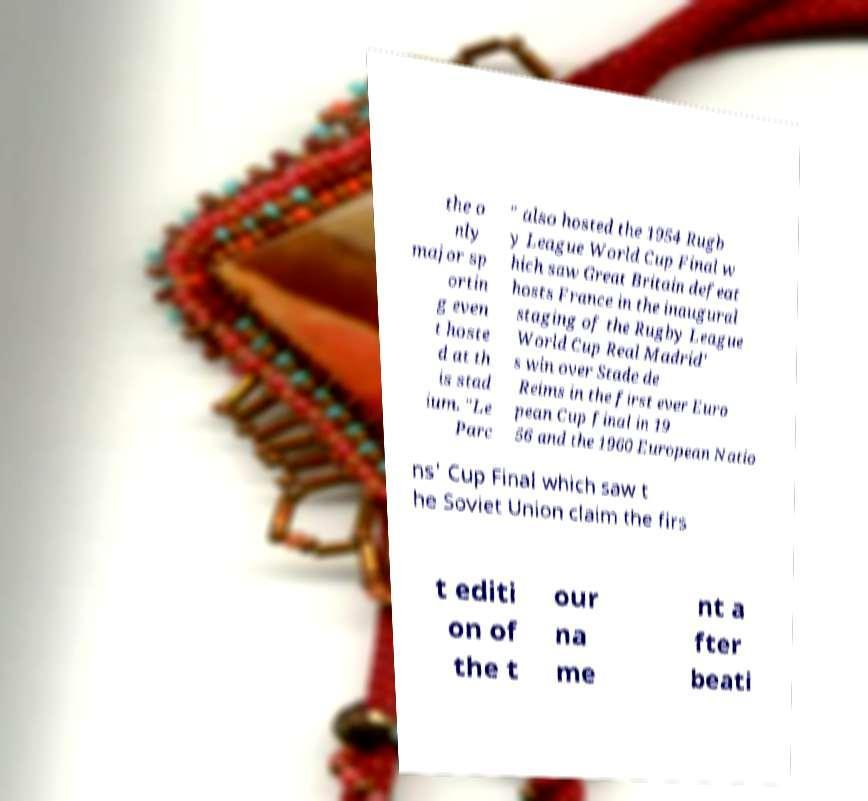Can you read and provide the text displayed in the image?This photo seems to have some interesting text. Can you extract and type it out for me? the o nly major sp ortin g even t hoste d at th is stad ium. "Le Parc " also hosted the 1954 Rugb y League World Cup Final w hich saw Great Britain defeat hosts France in the inaugural staging of the Rugby League World Cup Real Madrid' s win over Stade de Reims in the first ever Euro pean Cup final in 19 56 and the 1960 European Natio ns' Cup Final which saw t he Soviet Union claim the firs t editi on of the t our na me nt a fter beati 